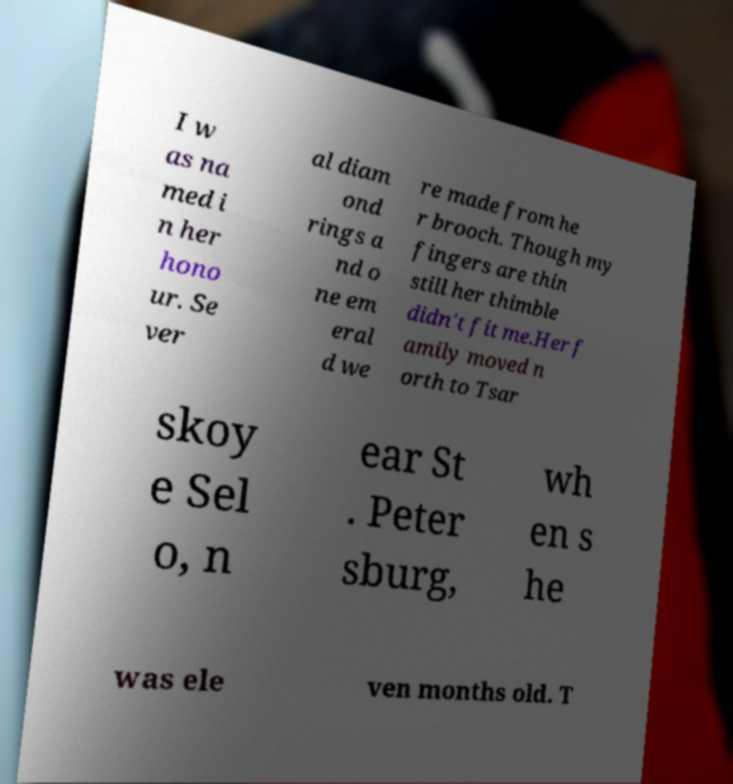For documentation purposes, I need the text within this image transcribed. Could you provide that? I w as na med i n her hono ur. Se ver al diam ond rings a nd o ne em eral d we re made from he r brooch. Though my fingers are thin still her thimble didn't fit me.Her f amily moved n orth to Tsar skoy e Sel o, n ear St . Peter sburg, wh en s he was ele ven months old. T 